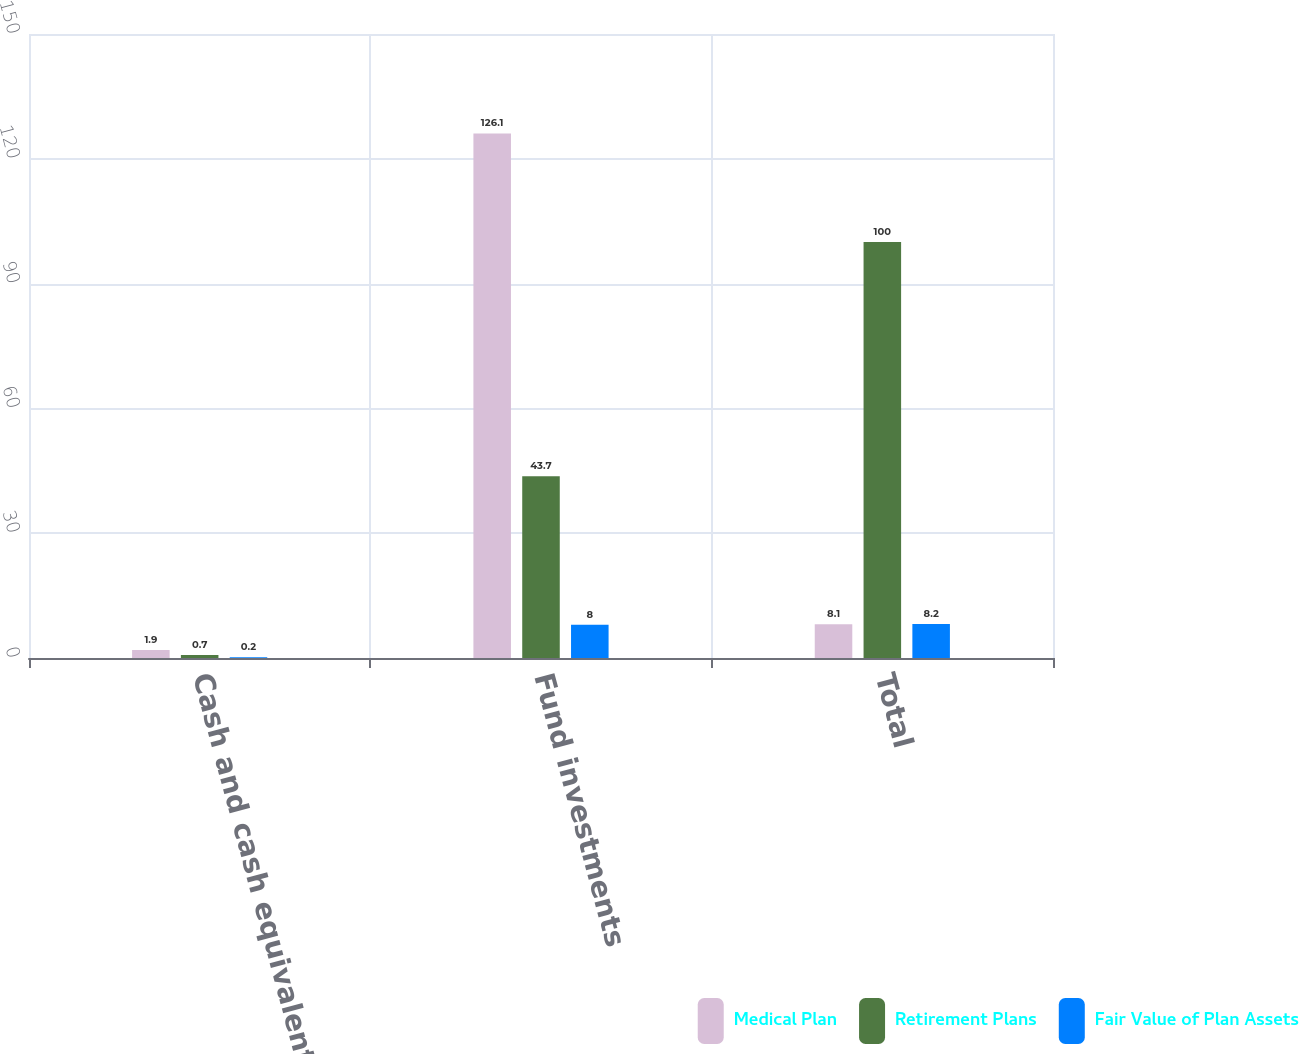<chart> <loc_0><loc_0><loc_500><loc_500><stacked_bar_chart><ecel><fcel>Cash and cash equivalents<fcel>Fund investments<fcel>Total<nl><fcel>Medical Plan<fcel>1.9<fcel>126.1<fcel>8.1<nl><fcel>Retirement Plans<fcel>0.7<fcel>43.7<fcel>100<nl><fcel>Fair Value of Plan Assets<fcel>0.2<fcel>8<fcel>8.2<nl></chart> 